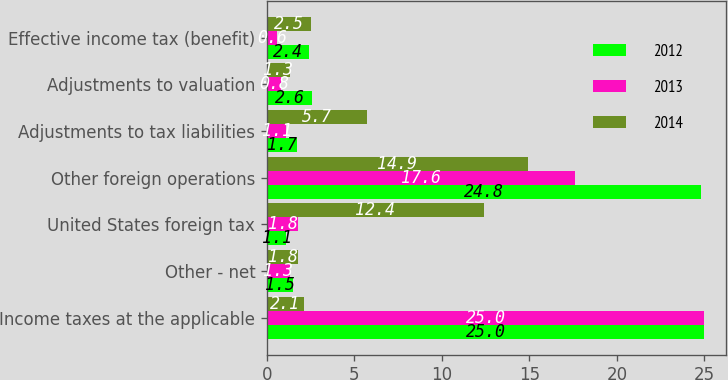<chart> <loc_0><loc_0><loc_500><loc_500><stacked_bar_chart><ecel><fcel>Income taxes at the applicable<fcel>Other - net<fcel>United States foreign tax<fcel>Other foreign operations<fcel>Adjustments to tax liabilities<fcel>Adjustments to valuation<fcel>Effective income tax (benefit)<nl><fcel>2012<fcel>25<fcel>1.5<fcel>1.1<fcel>24.8<fcel>1.7<fcel>2.6<fcel>2.4<nl><fcel>2013<fcel>25<fcel>1.3<fcel>1.8<fcel>17.6<fcel>1.1<fcel>0.8<fcel>0.6<nl><fcel>2014<fcel>2.1<fcel>1.8<fcel>12.4<fcel>14.9<fcel>5.7<fcel>1.3<fcel>2.5<nl></chart> 